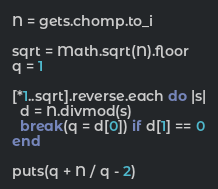Convert code to text. <code><loc_0><loc_0><loc_500><loc_500><_Ruby_>N = gets.chomp.to_i

sqrt = Math.sqrt(N).floor
q = 1

[*1..sqrt].reverse.each do |s|
  d = N.divmod(s)
  break(q = d[0]) if d[1] == 0
end

puts(q + N / q - 2)
</code> 